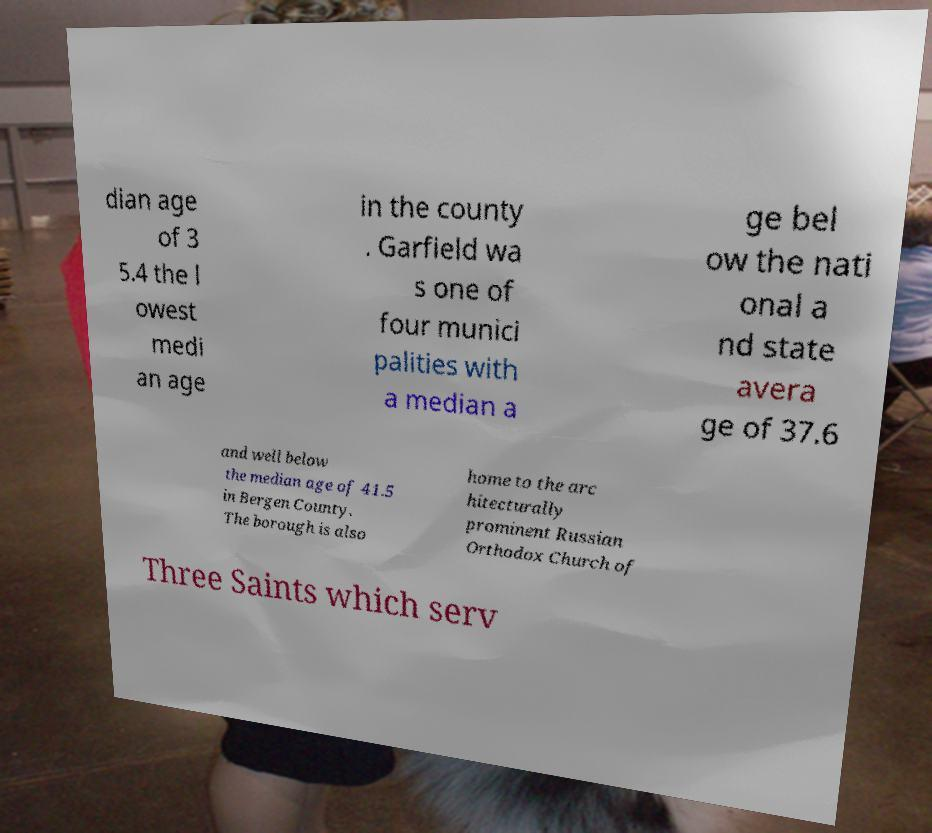I need the written content from this picture converted into text. Can you do that? dian age of 3 5.4 the l owest medi an age in the county . Garfield wa s one of four munici palities with a median a ge bel ow the nati onal a nd state avera ge of 37.6 and well below the median age of 41.5 in Bergen County. The borough is also home to the arc hitecturally prominent Russian Orthodox Church of Three Saints which serv 